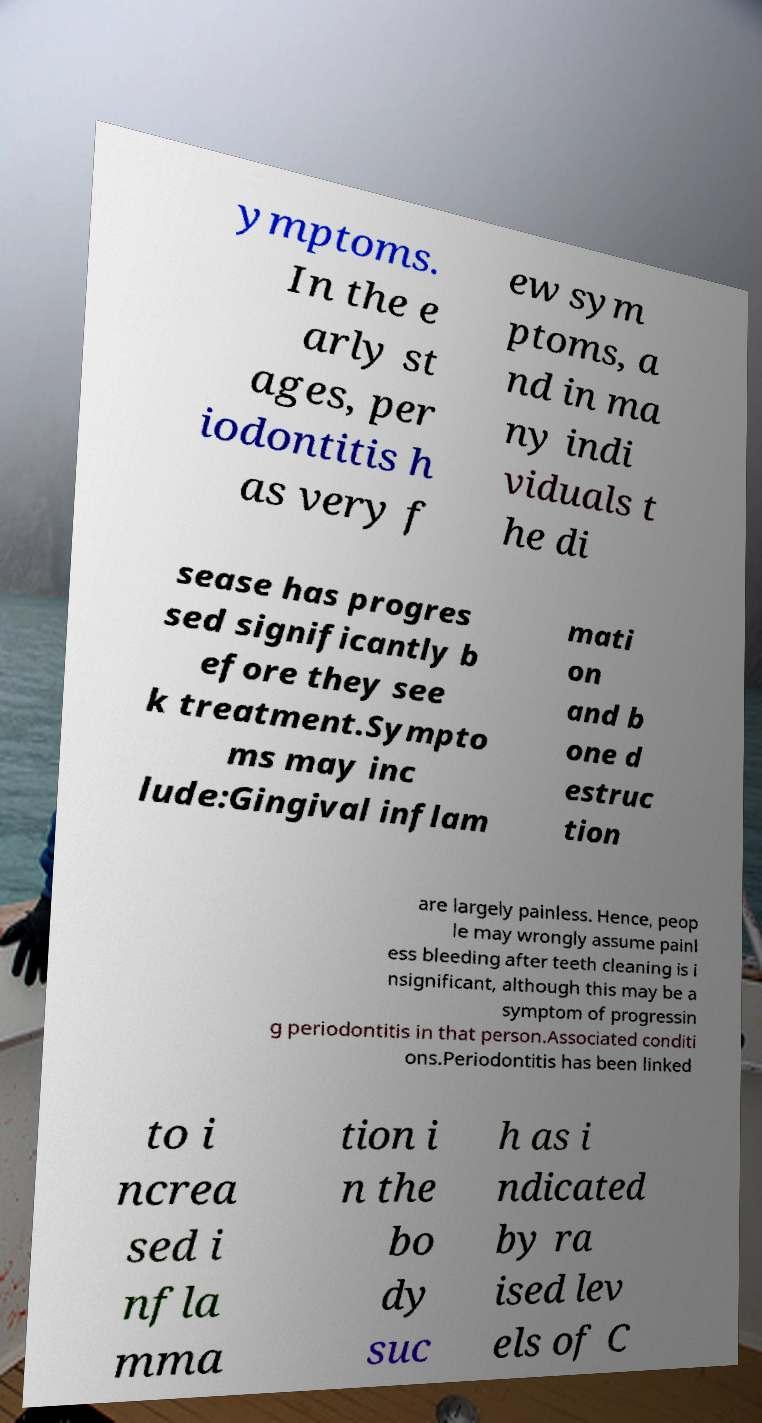I need the written content from this picture converted into text. Can you do that? ymptoms. In the e arly st ages, per iodontitis h as very f ew sym ptoms, a nd in ma ny indi viduals t he di sease has progres sed significantly b efore they see k treatment.Sympto ms may inc lude:Gingival inflam mati on and b one d estruc tion are largely painless. Hence, peop le may wrongly assume painl ess bleeding after teeth cleaning is i nsignificant, although this may be a symptom of progressin g periodontitis in that person.Associated conditi ons.Periodontitis has been linked to i ncrea sed i nfla mma tion i n the bo dy suc h as i ndicated by ra ised lev els of C 